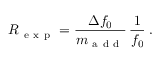Convert formula to latex. <formula><loc_0><loc_0><loc_500><loc_500>R _ { e x p } = \frac { \Delta f _ { 0 } } { m _ { a d d } } \, \frac { 1 } { f _ { 0 } } \, .</formula> 